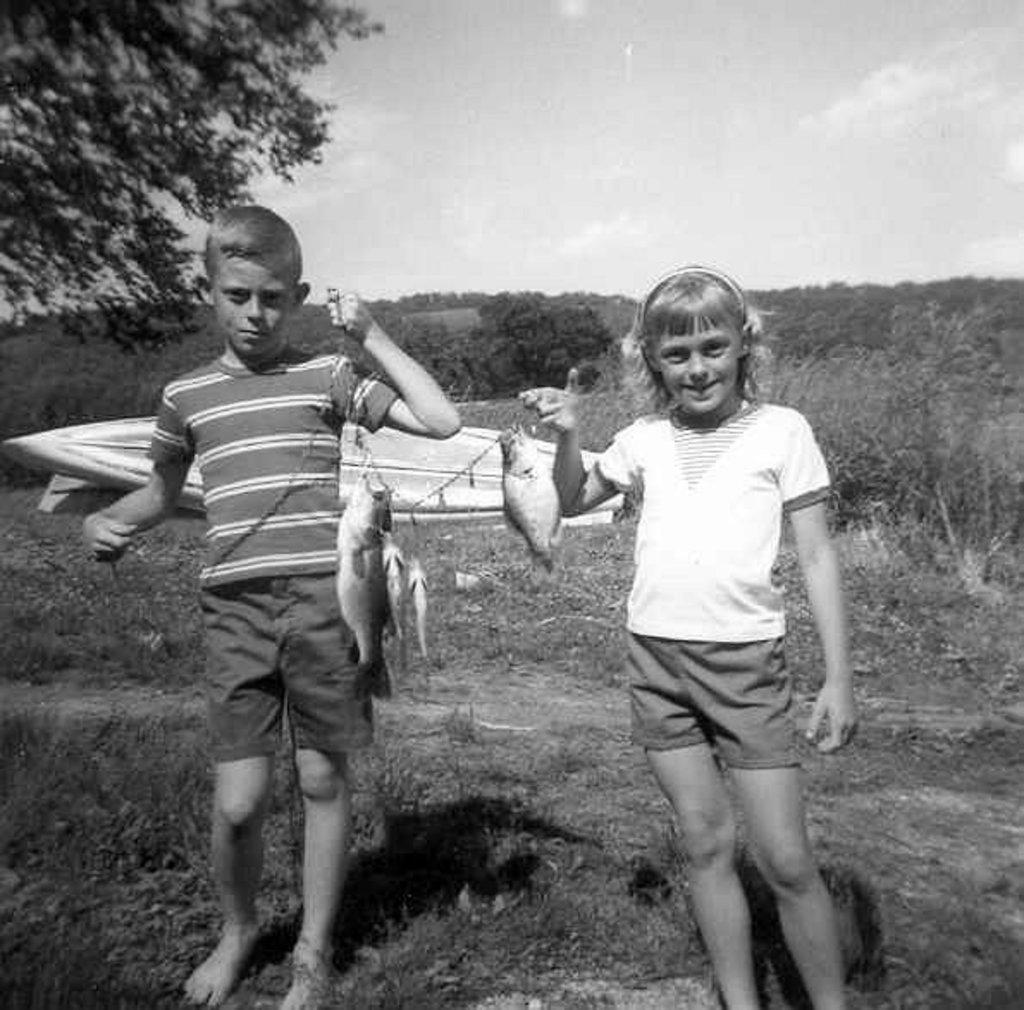What is the color scheme of the image? The image is black and white. Who are the people in the image? There is a boy and a girl in the image. What are the boy and girl holding? They are holding fishes. What is the ground made of in the image? There is grass on the ground in the image. What can be seen in the background of the image? There are trees and the sky visible in the background of the image. What type of paste is being used by the boy in the image? There is no paste present in the image; the boy is holding a fish. How many bulbs are visible in the image? There are no bulbs visible in the image. 